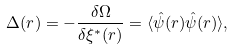Convert formula to latex. <formula><loc_0><loc_0><loc_500><loc_500>\Delta ( r ) = - { \frac { \delta \Omega } { \delta \xi ^ { \ast } ( r ) } } = \langle \hat { \psi } ( r ) \hat { \psi } ( r ) \rangle ,</formula> 